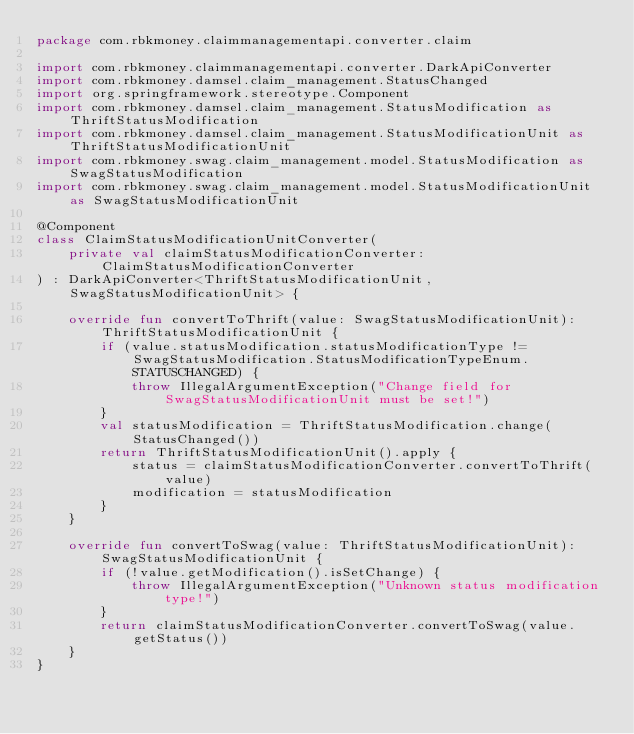<code> <loc_0><loc_0><loc_500><loc_500><_Kotlin_>package com.rbkmoney.claimmanagementapi.converter.claim

import com.rbkmoney.claimmanagementapi.converter.DarkApiConverter
import com.rbkmoney.damsel.claim_management.StatusChanged
import org.springframework.stereotype.Component
import com.rbkmoney.damsel.claim_management.StatusModification as ThriftStatusModification
import com.rbkmoney.damsel.claim_management.StatusModificationUnit as ThriftStatusModificationUnit
import com.rbkmoney.swag.claim_management.model.StatusModification as SwagStatusModification
import com.rbkmoney.swag.claim_management.model.StatusModificationUnit as SwagStatusModificationUnit

@Component
class ClaimStatusModificationUnitConverter(
    private val claimStatusModificationConverter: ClaimStatusModificationConverter
) : DarkApiConverter<ThriftStatusModificationUnit, SwagStatusModificationUnit> {

    override fun convertToThrift(value: SwagStatusModificationUnit): ThriftStatusModificationUnit {
        if (value.statusModification.statusModificationType != SwagStatusModification.StatusModificationTypeEnum.STATUSCHANGED) {
            throw IllegalArgumentException("Change field for SwagStatusModificationUnit must be set!")
        }
        val statusModification = ThriftStatusModification.change(StatusChanged())
        return ThriftStatusModificationUnit().apply {
            status = claimStatusModificationConverter.convertToThrift(value)
            modification = statusModification
        }
    }

    override fun convertToSwag(value: ThriftStatusModificationUnit): SwagStatusModificationUnit {
        if (!value.getModification().isSetChange) {
            throw IllegalArgumentException("Unknown status modification type!")
        }
        return claimStatusModificationConverter.convertToSwag(value.getStatus())
    }
}
</code> 